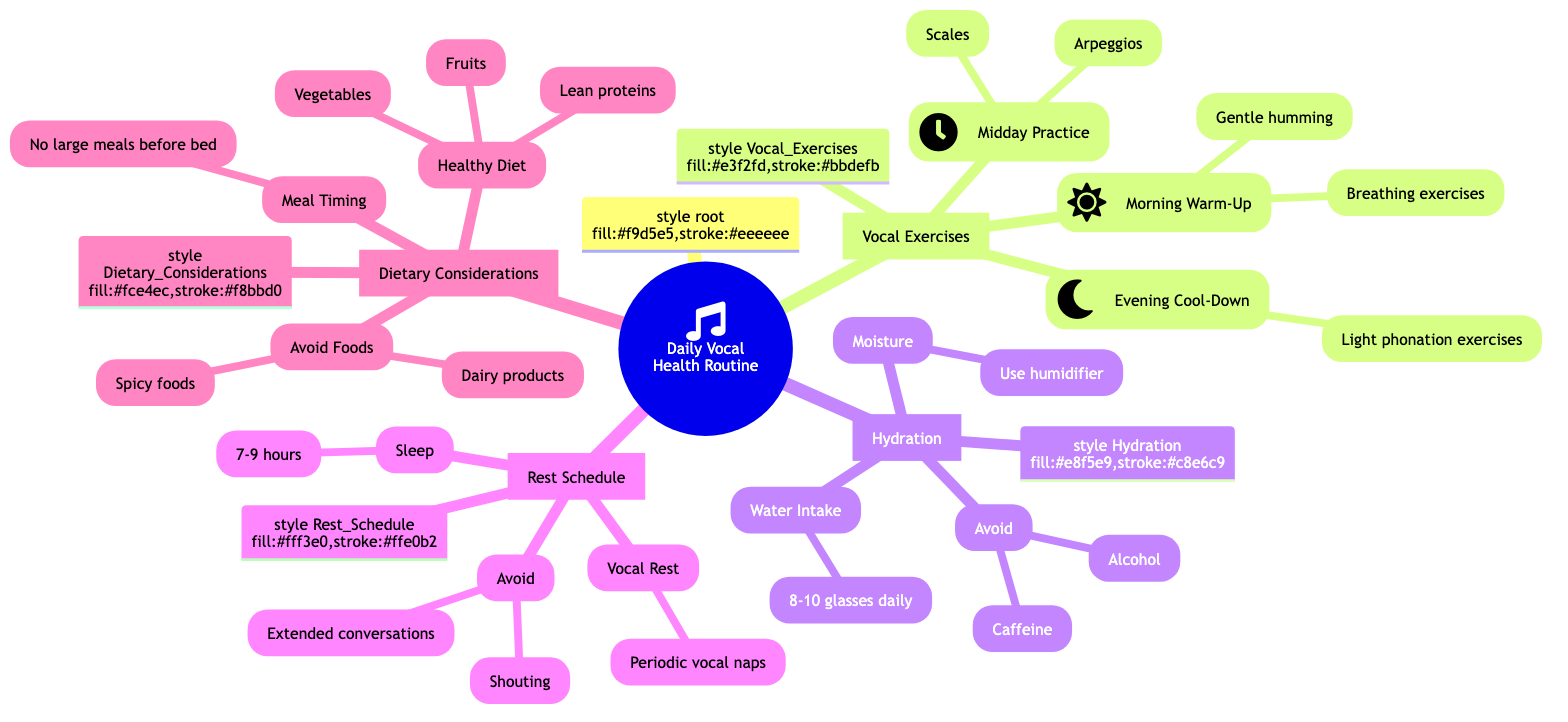What are the three types of vocal exercises listed? The diagram categorizes vocal exercises into three parts: Morning Warm-Up, Midday Practice, and Evening Cool-Down.
Answer: Morning Warm-Up, Midday Practice, Evening Cool-Down How many vocal exercises are mentioned? By counting the specific types of vocal exercises listed in the diagram, we see three distinct exercises under the category of Vocal Exercises.
Answer: 3 What should be avoided to maintain hydration? Looking at the Hydration section, it clearly states to avoid caffeinated and alcoholic beverages to prevent dehydration of the vocal cords.
Answer: Caffeinated and alcoholic beverages How many hours of quality sleep are recommended? The Rest Schedule section indicates that a range of 7-9 hours of sleep is recommended for vocal cord recovery, as stated under the Sleep entry.
Answer: 7-9 hours What is a dietary consideration to avoid? The Dietary Considerations section specifies avoiding dairy products and spicy foods as they can cause mucus production and irritation.
Answer: Dairy products and spicy foods What is one component of the Morning Warm-Up? Within the Morning Warm-Up of the Vocal Exercises section, breathing exercises and gentle humming are mentioned as components to start the day.
Answer: Breathing exercises What is the purpose of using a humidifier at home? In the Hydration section, the use of a humidifier is suggested for maintaining moisture, which aids in vocal health by preventing dryness.
Answer: Maintain moisture Which dietary consideration involves meal timing? The Dietary Considerations category mentions a specific meal timing guideline to avoid eating large meals close to bedtime, which helps prevent acid reflux.
Answer: Avoid eating large meals close to bedtime What aspect of vocal rest is emphasized? The Rest Schedule indicates the importance of periodic vocal naps during the day to avoid strain, which is critical for maintaining vocal health.
Answer: Periodic vocal naps 